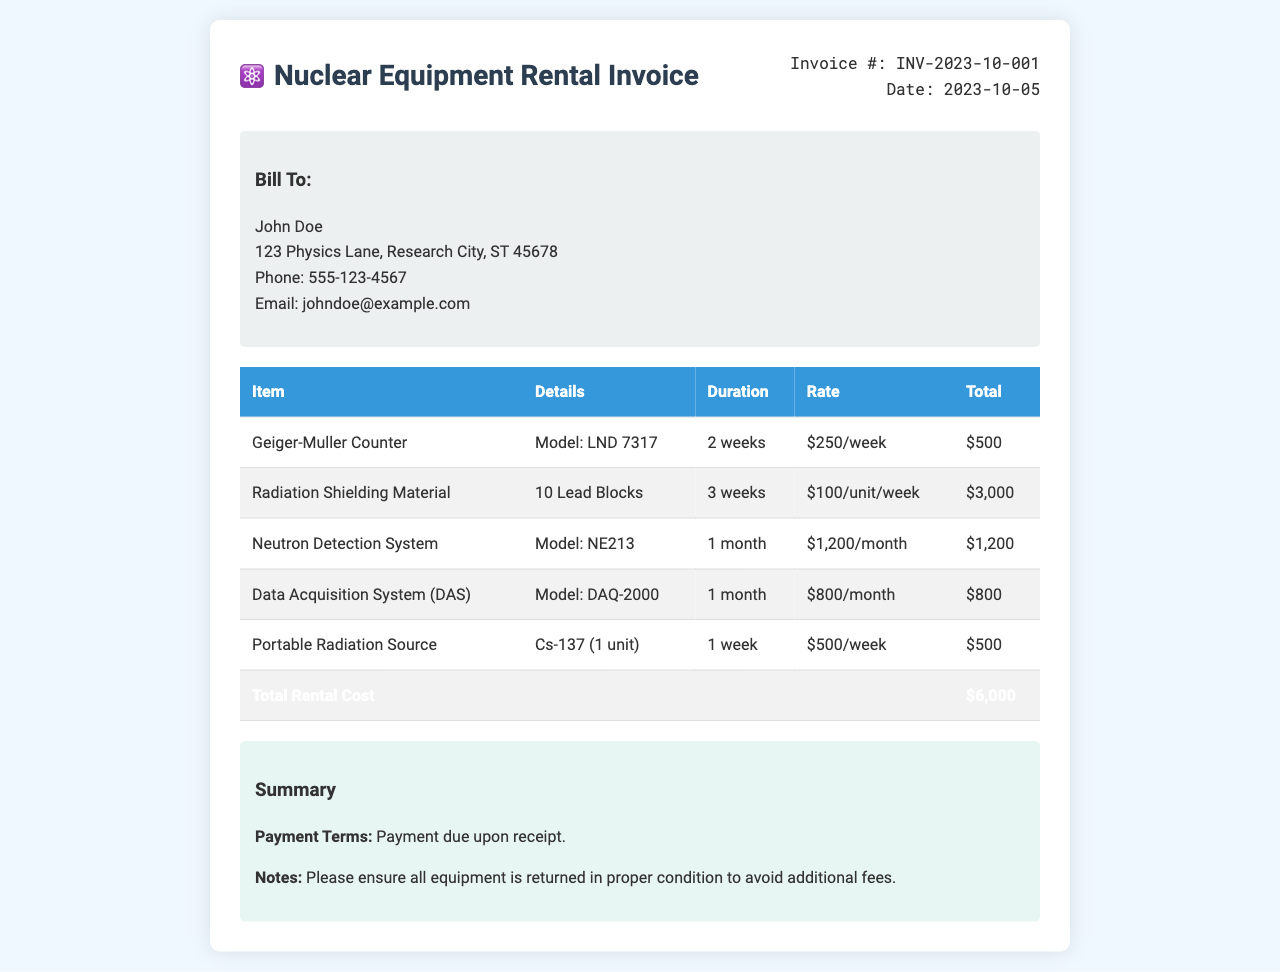What is the invoice number? The invoice number is listed at the top of the document under "Invoice #."
Answer: INV-2023-10-001 What is the total rental cost? The total rental cost is found at the bottom of the itemized table under "Total Rental Cost."
Answer: $6,000 How many lead blocks are listed in the radiation shielding material? The details of the radiation shielding material state "10 Lead Blocks."
Answer: 10 Lead Blocks How long is the Geiger-Muller Counter rented for? The rental duration for the Geiger-Muller Counter is mentioned in the table under "Duration."
Answer: 2 weeks What is the payment term? The payment terms are noted in the summary section of the invoice.
Answer: Payment due upon receipt How much is the rate for the Neutron Detection System? The rate is specified in the itemized list next to the Neutron Detection System.
Answer: $1,200/month What model is the Data Acquisition System? The model of the Data Acquisition System is provided under the details column in the table.
Answer: DAQ-2000 What is the date of the invoice? The date is stated in the invoice details section.
Answer: 2023-10-05 